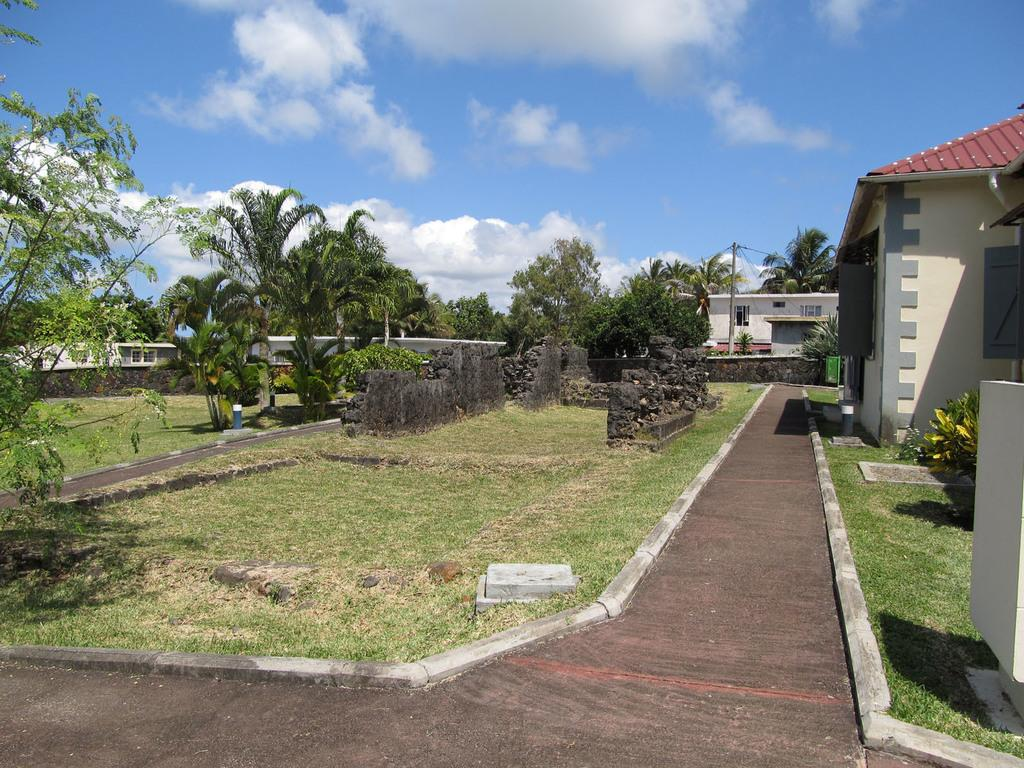What type of structures can be seen in the image? There are buildings in the image. What architectural elements are present in the image? There are walls in the image. What type of vegetation is visible in the image? There are trees and plants in the image. What type of ground cover is present in the image? There is grass visible in the image. What part of the natural environment is visible in the background of the image? The sky is visible in the background of the image. Can you tell me how many times the person in the image grips the spot before kissing it? There is no person or act of gripping or kissing present in the image; it features buildings, walls, trees, plants, grass, and the sky. 